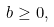Convert formula to latex. <formula><loc_0><loc_0><loc_500><loc_500>b \geq 0 ,</formula> 